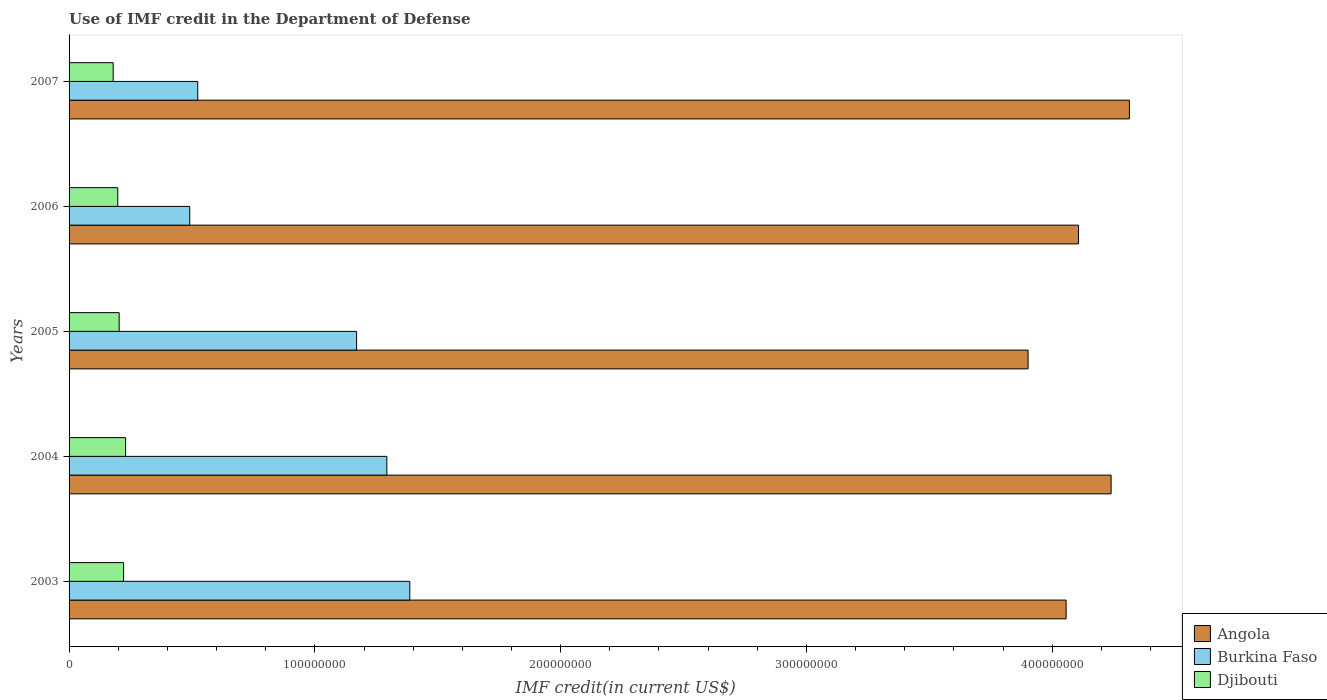How many different coloured bars are there?
Your response must be concise. 3. How many groups of bars are there?
Give a very brief answer. 5. Are the number of bars on each tick of the Y-axis equal?
Your answer should be compact. Yes. How many bars are there on the 3rd tick from the top?
Your response must be concise. 3. In how many cases, is the number of bars for a given year not equal to the number of legend labels?
Make the answer very short. 0. What is the IMF credit in the Department of Defense in Burkina Faso in 2005?
Your answer should be very brief. 1.17e+08. Across all years, what is the maximum IMF credit in the Department of Defense in Djibouti?
Your answer should be very brief. 2.30e+07. Across all years, what is the minimum IMF credit in the Department of Defense in Djibouti?
Provide a short and direct response. 1.79e+07. What is the total IMF credit in the Department of Defense in Angola in the graph?
Make the answer very short. 2.06e+09. What is the difference between the IMF credit in the Department of Defense in Djibouti in 2003 and that in 2006?
Provide a short and direct response. 2.37e+06. What is the difference between the IMF credit in the Department of Defense in Djibouti in 2007 and the IMF credit in the Department of Defense in Angola in 2003?
Offer a very short reply. -3.88e+08. What is the average IMF credit in the Department of Defense in Burkina Faso per year?
Give a very brief answer. 9.73e+07. In the year 2003, what is the difference between the IMF credit in the Department of Defense in Burkina Faso and IMF credit in the Department of Defense in Angola?
Ensure brevity in your answer.  -2.67e+08. What is the ratio of the IMF credit in the Department of Defense in Angola in 2006 to that in 2007?
Provide a short and direct response. 0.95. Is the difference between the IMF credit in the Department of Defense in Burkina Faso in 2005 and 2007 greater than the difference between the IMF credit in the Department of Defense in Angola in 2005 and 2007?
Your answer should be very brief. Yes. What is the difference between the highest and the second highest IMF credit in the Department of Defense in Angola?
Your response must be concise. 7.44e+06. What is the difference between the highest and the lowest IMF credit in the Department of Defense in Burkina Faso?
Your answer should be very brief. 8.95e+07. In how many years, is the IMF credit in the Department of Defense in Angola greater than the average IMF credit in the Department of Defense in Angola taken over all years?
Your answer should be very brief. 2. What does the 1st bar from the top in 2005 represents?
Keep it short and to the point. Djibouti. What does the 3rd bar from the bottom in 2005 represents?
Your answer should be compact. Djibouti. How many bars are there?
Provide a succinct answer. 15. How many years are there in the graph?
Make the answer very short. 5. Are the values on the major ticks of X-axis written in scientific E-notation?
Offer a very short reply. No. Does the graph contain any zero values?
Provide a short and direct response. No. Does the graph contain grids?
Give a very brief answer. No. What is the title of the graph?
Your answer should be compact. Use of IMF credit in the Department of Defense. What is the label or title of the X-axis?
Make the answer very short. IMF credit(in current US$). What is the IMF credit(in current US$) of Angola in 2003?
Your answer should be compact. 4.06e+08. What is the IMF credit(in current US$) in Burkina Faso in 2003?
Keep it short and to the point. 1.39e+08. What is the IMF credit(in current US$) of Djibouti in 2003?
Your answer should be compact. 2.22e+07. What is the IMF credit(in current US$) of Angola in 2004?
Make the answer very short. 4.24e+08. What is the IMF credit(in current US$) in Burkina Faso in 2004?
Provide a succinct answer. 1.29e+08. What is the IMF credit(in current US$) in Djibouti in 2004?
Keep it short and to the point. 2.30e+07. What is the IMF credit(in current US$) of Angola in 2005?
Your answer should be very brief. 3.90e+08. What is the IMF credit(in current US$) in Burkina Faso in 2005?
Your answer should be very brief. 1.17e+08. What is the IMF credit(in current US$) in Djibouti in 2005?
Your response must be concise. 2.04e+07. What is the IMF credit(in current US$) in Angola in 2006?
Make the answer very short. 4.11e+08. What is the IMF credit(in current US$) in Burkina Faso in 2006?
Offer a very short reply. 4.91e+07. What is the IMF credit(in current US$) in Djibouti in 2006?
Make the answer very short. 1.98e+07. What is the IMF credit(in current US$) in Angola in 2007?
Provide a short and direct response. 4.31e+08. What is the IMF credit(in current US$) in Burkina Faso in 2007?
Provide a succinct answer. 5.24e+07. What is the IMF credit(in current US$) of Djibouti in 2007?
Provide a succinct answer. 1.79e+07. Across all years, what is the maximum IMF credit(in current US$) of Angola?
Provide a short and direct response. 4.31e+08. Across all years, what is the maximum IMF credit(in current US$) of Burkina Faso?
Your answer should be very brief. 1.39e+08. Across all years, what is the maximum IMF credit(in current US$) in Djibouti?
Ensure brevity in your answer.  2.30e+07. Across all years, what is the minimum IMF credit(in current US$) of Angola?
Offer a very short reply. 3.90e+08. Across all years, what is the minimum IMF credit(in current US$) of Burkina Faso?
Offer a very short reply. 4.91e+07. Across all years, what is the minimum IMF credit(in current US$) of Djibouti?
Your response must be concise. 1.79e+07. What is the total IMF credit(in current US$) in Angola in the graph?
Make the answer very short. 2.06e+09. What is the total IMF credit(in current US$) of Burkina Faso in the graph?
Offer a terse response. 4.86e+08. What is the total IMF credit(in current US$) of Djibouti in the graph?
Ensure brevity in your answer.  1.03e+08. What is the difference between the IMF credit(in current US$) in Angola in 2003 and that in 2004?
Offer a terse response. -1.83e+07. What is the difference between the IMF credit(in current US$) of Burkina Faso in 2003 and that in 2004?
Provide a short and direct response. 9.34e+06. What is the difference between the IMF credit(in current US$) of Djibouti in 2003 and that in 2004?
Give a very brief answer. -8.12e+05. What is the difference between the IMF credit(in current US$) in Angola in 2003 and that in 2005?
Keep it short and to the point. 1.55e+07. What is the difference between the IMF credit(in current US$) in Burkina Faso in 2003 and that in 2005?
Offer a very short reply. 2.17e+07. What is the difference between the IMF credit(in current US$) in Djibouti in 2003 and that in 2005?
Provide a short and direct response. 1.80e+06. What is the difference between the IMF credit(in current US$) of Angola in 2003 and that in 2006?
Ensure brevity in your answer.  -5.03e+06. What is the difference between the IMF credit(in current US$) of Burkina Faso in 2003 and that in 2006?
Provide a short and direct response. 8.95e+07. What is the difference between the IMF credit(in current US$) of Djibouti in 2003 and that in 2006?
Provide a short and direct response. 2.37e+06. What is the difference between the IMF credit(in current US$) of Angola in 2003 and that in 2007?
Keep it short and to the point. -2.57e+07. What is the difference between the IMF credit(in current US$) in Burkina Faso in 2003 and that in 2007?
Keep it short and to the point. 8.63e+07. What is the difference between the IMF credit(in current US$) in Djibouti in 2003 and that in 2007?
Provide a short and direct response. 4.24e+06. What is the difference between the IMF credit(in current US$) of Angola in 2004 and that in 2005?
Provide a succinct answer. 3.38e+07. What is the difference between the IMF credit(in current US$) in Burkina Faso in 2004 and that in 2005?
Your response must be concise. 1.23e+07. What is the difference between the IMF credit(in current US$) of Djibouti in 2004 and that in 2005?
Provide a short and direct response. 2.61e+06. What is the difference between the IMF credit(in current US$) in Angola in 2004 and that in 2006?
Offer a terse response. 1.33e+07. What is the difference between the IMF credit(in current US$) of Burkina Faso in 2004 and that in 2006?
Make the answer very short. 8.02e+07. What is the difference between the IMF credit(in current US$) in Djibouti in 2004 and that in 2006?
Offer a very short reply. 3.18e+06. What is the difference between the IMF credit(in current US$) of Angola in 2004 and that in 2007?
Your answer should be compact. -7.44e+06. What is the difference between the IMF credit(in current US$) of Burkina Faso in 2004 and that in 2007?
Ensure brevity in your answer.  7.69e+07. What is the difference between the IMF credit(in current US$) in Djibouti in 2004 and that in 2007?
Provide a succinct answer. 5.05e+06. What is the difference between the IMF credit(in current US$) in Angola in 2005 and that in 2006?
Give a very brief answer. -2.05e+07. What is the difference between the IMF credit(in current US$) in Burkina Faso in 2005 and that in 2006?
Provide a succinct answer. 6.79e+07. What is the difference between the IMF credit(in current US$) of Djibouti in 2005 and that in 2006?
Offer a very short reply. 5.70e+05. What is the difference between the IMF credit(in current US$) of Angola in 2005 and that in 2007?
Your response must be concise. -4.12e+07. What is the difference between the IMF credit(in current US$) of Burkina Faso in 2005 and that in 2007?
Ensure brevity in your answer.  6.46e+07. What is the difference between the IMF credit(in current US$) in Djibouti in 2005 and that in 2007?
Ensure brevity in your answer.  2.44e+06. What is the difference between the IMF credit(in current US$) in Angola in 2006 and that in 2007?
Make the answer very short. -2.07e+07. What is the difference between the IMF credit(in current US$) of Burkina Faso in 2006 and that in 2007?
Make the answer very short. -3.27e+06. What is the difference between the IMF credit(in current US$) in Djibouti in 2006 and that in 2007?
Your response must be concise. 1.87e+06. What is the difference between the IMF credit(in current US$) of Angola in 2003 and the IMF credit(in current US$) of Burkina Faso in 2004?
Give a very brief answer. 2.76e+08. What is the difference between the IMF credit(in current US$) of Angola in 2003 and the IMF credit(in current US$) of Djibouti in 2004?
Offer a very short reply. 3.83e+08. What is the difference between the IMF credit(in current US$) in Burkina Faso in 2003 and the IMF credit(in current US$) in Djibouti in 2004?
Provide a short and direct response. 1.16e+08. What is the difference between the IMF credit(in current US$) of Angola in 2003 and the IMF credit(in current US$) of Burkina Faso in 2005?
Offer a terse response. 2.89e+08. What is the difference between the IMF credit(in current US$) of Angola in 2003 and the IMF credit(in current US$) of Djibouti in 2005?
Your response must be concise. 3.85e+08. What is the difference between the IMF credit(in current US$) in Burkina Faso in 2003 and the IMF credit(in current US$) in Djibouti in 2005?
Provide a succinct answer. 1.18e+08. What is the difference between the IMF credit(in current US$) of Angola in 2003 and the IMF credit(in current US$) of Burkina Faso in 2006?
Provide a succinct answer. 3.57e+08. What is the difference between the IMF credit(in current US$) of Angola in 2003 and the IMF credit(in current US$) of Djibouti in 2006?
Your answer should be very brief. 3.86e+08. What is the difference between the IMF credit(in current US$) of Burkina Faso in 2003 and the IMF credit(in current US$) of Djibouti in 2006?
Your response must be concise. 1.19e+08. What is the difference between the IMF credit(in current US$) in Angola in 2003 and the IMF credit(in current US$) in Burkina Faso in 2007?
Your answer should be very brief. 3.53e+08. What is the difference between the IMF credit(in current US$) of Angola in 2003 and the IMF credit(in current US$) of Djibouti in 2007?
Offer a terse response. 3.88e+08. What is the difference between the IMF credit(in current US$) in Burkina Faso in 2003 and the IMF credit(in current US$) in Djibouti in 2007?
Provide a succinct answer. 1.21e+08. What is the difference between the IMF credit(in current US$) in Angola in 2004 and the IMF credit(in current US$) in Burkina Faso in 2005?
Provide a short and direct response. 3.07e+08. What is the difference between the IMF credit(in current US$) in Angola in 2004 and the IMF credit(in current US$) in Djibouti in 2005?
Offer a terse response. 4.04e+08. What is the difference between the IMF credit(in current US$) in Burkina Faso in 2004 and the IMF credit(in current US$) in Djibouti in 2005?
Provide a short and direct response. 1.09e+08. What is the difference between the IMF credit(in current US$) in Angola in 2004 and the IMF credit(in current US$) in Burkina Faso in 2006?
Your answer should be very brief. 3.75e+08. What is the difference between the IMF credit(in current US$) of Angola in 2004 and the IMF credit(in current US$) of Djibouti in 2006?
Make the answer very short. 4.04e+08. What is the difference between the IMF credit(in current US$) of Burkina Faso in 2004 and the IMF credit(in current US$) of Djibouti in 2006?
Your answer should be very brief. 1.09e+08. What is the difference between the IMF credit(in current US$) of Angola in 2004 and the IMF credit(in current US$) of Burkina Faso in 2007?
Your answer should be very brief. 3.72e+08. What is the difference between the IMF credit(in current US$) in Angola in 2004 and the IMF credit(in current US$) in Djibouti in 2007?
Give a very brief answer. 4.06e+08. What is the difference between the IMF credit(in current US$) in Burkina Faso in 2004 and the IMF credit(in current US$) in Djibouti in 2007?
Ensure brevity in your answer.  1.11e+08. What is the difference between the IMF credit(in current US$) in Angola in 2005 and the IMF credit(in current US$) in Burkina Faso in 2006?
Make the answer very short. 3.41e+08. What is the difference between the IMF credit(in current US$) in Angola in 2005 and the IMF credit(in current US$) in Djibouti in 2006?
Offer a very short reply. 3.70e+08. What is the difference between the IMF credit(in current US$) in Burkina Faso in 2005 and the IMF credit(in current US$) in Djibouti in 2006?
Provide a short and direct response. 9.72e+07. What is the difference between the IMF credit(in current US$) in Angola in 2005 and the IMF credit(in current US$) in Burkina Faso in 2007?
Provide a short and direct response. 3.38e+08. What is the difference between the IMF credit(in current US$) in Angola in 2005 and the IMF credit(in current US$) in Djibouti in 2007?
Offer a terse response. 3.72e+08. What is the difference between the IMF credit(in current US$) in Burkina Faso in 2005 and the IMF credit(in current US$) in Djibouti in 2007?
Your answer should be very brief. 9.90e+07. What is the difference between the IMF credit(in current US$) of Angola in 2006 and the IMF credit(in current US$) of Burkina Faso in 2007?
Your answer should be compact. 3.58e+08. What is the difference between the IMF credit(in current US$) of Angola in 2006 and the IMF credit(in current US$) of Djibouti in 2007?
Keep it short and to the point. 3.93e+08. What is the difference between the IMF credit(in current US$) in Burkina Faso in 2006 and the IMF credit(in current US$) in Djibouti in 2007?
Offer a very short reply. 3.11e+07. What is the average IMF credit(in current US$) of Angola per year?
Make the answer very short. 4.12e+08. What is the average IMF credit(in current US$) in Burkina Faso per year?
Offer a terse response. 9.73e+07. What is the average IMF credit(in current US$) in Djibouti per year?
Provide a succinct answer. 2.07e+07. In the year 2003, what is the difference between the IMF credit(in current US$) in Angola and IMF credit(in current US$) in Burkina Faso?
Offer a terse response. 2.67e+08. In the year 2003, what is the difference between the IMF credit(in current US$) of Angola and IMF credit(in current US$) of Djibouti?
Offer a terse response. 3.83e+08. In the year 2003, what is the difference between the IMF credit(in current US$) in Burkina Faso and IMF credit(in current US$) in Djibouti?
Ensure brevity in your answer.  1.16e+08. In the year 2004, what is the difference between the IMF credit(in current US$) in Angola and IMF credit(in current US$) in Burkina Faso?
Provide a short and direct response. 2.95e+08. In the year 2004, what is the difference between the IMF credit(in current US$) in Angola and IMF credit(in current US$) in Djibouti?
Give a very brief answer. 4.01e+08. In the year 2004, what is the difference between the IMF credit(in current US$) in Burkina Faso and IMF credit(in current US$) in Djibouti?
Your answer should be very brief. 1.06e+08. In the year 2005, what is the difference between the IMF credit(in current US$) in Angola and IMF credit(in current US$) in Burkina Faso?
Give a very brief answer. 2.73e+08. In the year 2005, what is the difference between the IMF credit(in current US$) in Angola and IMF credit(in current US$) in Djibouti?
Keep it short and to the point. 3.70e+08. In the year 2005, what is the difference between the IMF credit(in current US$) of Burkina Faso and IMF credit(in current US$) of Djibouti?
Offer a terse response. 9.66e+07. In the year 2006, what is the difference between the IMF credit(in current US$) in Angola and IMF credit(in current US$) in Burkina Faso?
Give a very brief answer. 3.62e+08. In the year 2006, what is the difference between the IMF credit(in current US$) in Angola and IMF credit(in current US$) in Djibouti?
Provide a succinct answer. 3.91e+08. In the year 2006, what is the difference between the IMF credit(in current US$) in Burkina Faso and IMF credit(in current US$) in Djibouti?
Your answer should be very brief. 2.93e+07. In the year 2007, what is the difference between the IMF credit(in current US$) of Angola and IMF credit(in current US$) of Burkina Faso?
Offer a terse response. 3.79e+08. In the year 2007, what is the difference between the IMF credit(in current US$) of Angola and IMF credit(in current US$) of Djibouti?
Give a very brief answer. 4.13e+08. In the year 2007, what is the difference between the IMF credit(in current US$) of Burkina Faso and IMF credit(in current US$) of Djibouti?
Make the answer very short. 3.44e+07. What is the ratio of the IMF credit(in current US$) in Angola in 2003 to that in 2004?
Your answer should be very brief. 0.96. What is the ratio of the IMF credit(in current US$) in Burkina Faso in 2003 to that in 2004?
Provide a short and direct response. 1.07. What is the ratio of the IMF credit(in current US$) of Djibouti in 2003 to that in 2004?
Give a very brief answer. 0.96. What is the ratio of the IMF credit(in current US$) of Angola in 2003 to that in 2005?
Your answer should be very brief. 1.04. What is the ratio of the IMF credit(in current US$) of Burkina Faso in 2003 to that in 2005?
Keep it short and to the point. 1.19. What is the ratio of the IMF credit(in current US$) in Djibouti in 2003 to that in 2005?
Your response must be concise. 1.09. What is the ratio of the IMF credit(in current US$) in Burkina Faso in 2003 to that in 2006?
Your answer should be very brief. 2.82. What is the ratio of the IMF credit(in current US$) in Djibouti in 2003 to that in 2006?
Provide a short and direct response. 1.12. What is the ratio of the IMF credit(in current US$) of Angola in 2003 to that in 2007?
Offer a very short reply. 0.94. What is the ratio of the IMF credit(in current US$) of Burkina Faso in 2003 to that in 2007?
Your answer should be very brief. 2.65. What is the ratio of the IMF credit(in current US$) of Djibouti in 2003 to that in 2007?
Keep it short and to the point. 1.24. What is the ratio of the IMF credit(in current US$) of Angola in 2004 to that in 2005?
Provide a succinct answer. 1.09. What is the ratio of the IMF credit(in current US$) in Burkina Faso in 2004 to that in 2005?
Your answer should be compact. 1.11. What is the ratio of the IMF credit(in current US$) in Djibouti in 2004 to that in 2005?
Your answer should be compact. 1.13. What is the ratio of the IMF credit(in current US$) in Angola in 2004 to that in 2006?
Ensure brevity in your answer.  1.03. What is the ratio of the IMF credit(in current US$) of Burkina Faso in 2004 to that in 2006?
Your answer should be very brief. 2.63. What is the ratio of the IMF credit(in current US$) of Djibouti in 2004 to that in 2006?
Provide a short and direct response. 1.16. What is the ratio of the IMF credit(in current US$) in Angola in 2004 to that in 2007?
Your answer should be compact. 0.98. What is the ratio of the IMF credit(in current US$) of Burkina Faso in 2004 to that in 2007?
Your response must be concise. 2.47. What is the ratio of the IMF credit(in current US$) in Djibouti in 2004 to that in 2007?
Provide a short and direct response. 1.28. What is the ratio of the IMF credit(in current US$) of Angola in 2005 to that in 2006?
Provide a short and direct response. 0.95. What is the ratio of the IMF credit(in current US$) in Burkina Faso in 2005 to that in 2006?
Provide a short and direct response. 2.38. What is the ratio of the IMF credit(in current US$) of Djibouti in 2005 to that in 2006?
Keep it short and to the point. 1.03. What is the ratio of the IMF credit(in current US$) of Angola in 2005 to that in 2007?
Offer a terse response. 0.9. What is the ratio of the IMF credit(in current US$) in Burkina Faso in 2005 to that in 2007?
Keep it short and to the point. 2.23. What is the ratio of the IMF credit(in current US$) in Djibouti in 2005 to that in 2007?
Offer a terse response. 1.14. What is the ratio of the IMF credit(in current US$) in Burkina Faso in 2006 to that in 2007?
Provide a succinct answer. 0.94. What is the ratio of the IMF credit(in current US$) in Djibouti in 2006 to that in 2007?
Ensure brevity in your answer.  1.1. What is the difference between the highest and the second highest IMF credit(in current US$) of Angola?
Offer a very short reply. 7.44e+06. What is the difference between the highest and the second highest IMF credit(in current US$) in Burkina Faso?
Provide a short and direct response. 9.34e+06. What is the difference between the highest and the second highest IMF credit(in current US$) of Djibouti?
Keep it short and to the point. 8.12e+05. What is the difference between the highest and the lowest IMF credit(in current US$) in Angola?
Your answer should be very brief. 4.12e+07. What is the difference between the highest and the lowest IMF credit(in current US$) in Burkina Faso?
Offer a very short reply. 8.95e+07. What is the difference between the highest and the lowest IMF credit(in current US$) in Djibouti?
Ensure brevity in your answer.  5.05e+06. 